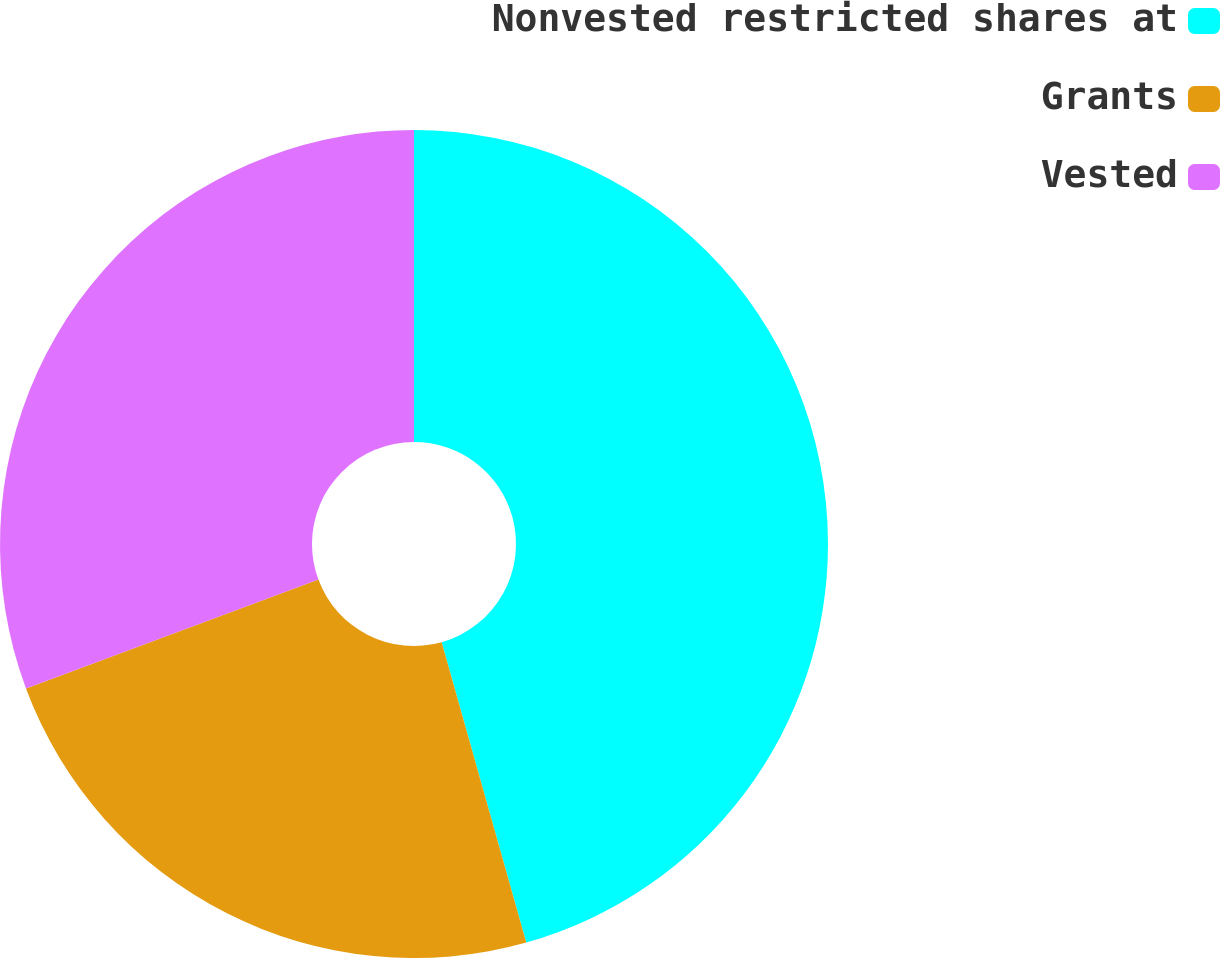Convert chart. <chart><loc_0><loc_0><loc_500><loc_500><pie_chart><fcel>Nonvested restricted shares at<fcel>Grants<fcel>Vested<nl><fcel>45.63%<fcel>23.7%<fcel>30.67%<nl></chart> 